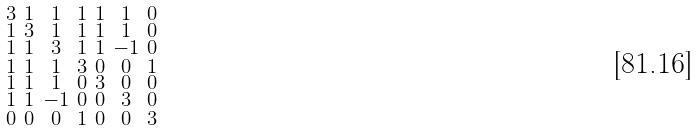Convert formula to latex. <formula><loc_0><loc_0><loc_500><loc_500>\begin{smallmatrix} 3 & 1 & 1 & 1 & 1 & 1 & 0 \\ 1 & 3 & 1 & 1 & 1 & 1 & 0 \\ 1 & 1 & 3 & 1 & 1 & - 1 & 0 \\ 1 & 1 & 1 & 3 & 0 & 0 & 1 \\ 1 & 1 & 1 & 0 & 3 & 0 & 0 \\ 1 & 1 & - 1 & 0 & 0 & 3 & 0 \\ 0 & 0 & 0 & 1 & 0 & 0 & 3 \end{smallmatrix}</formula> 